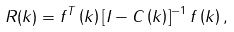<formula> <loc_0><loc_0><loc_500><loc_500>R ( k ) = { f } ^ { T } \left ( k \right ) \left [ { I } - { C } \left ( k \right ) \right ] ^ { - 1 } { f } \left ( k \right ) ,</formula> 